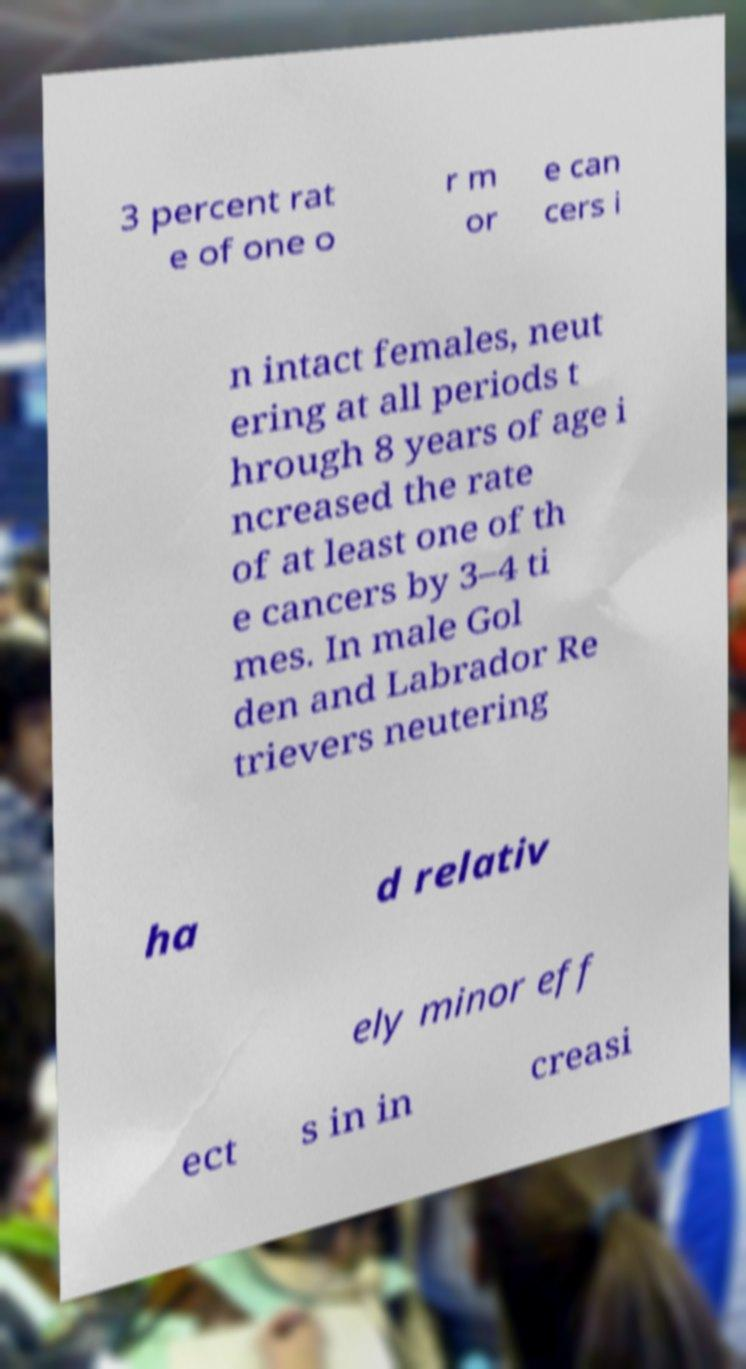Can you read and provide the text displayed in the image?This photo seems to have some interesting text. Can you extract and type it out for me? 3 percent rat e of one o r m or e can cers i n intact females, neut ering at all periods t hrough 8 years of age i ncreased the rate of at least one of th e cancers by 3–4 ti mes. In male Gol den and Labrador Re trievers neutering ha d relativ ely minor eff ect s in in creasi 